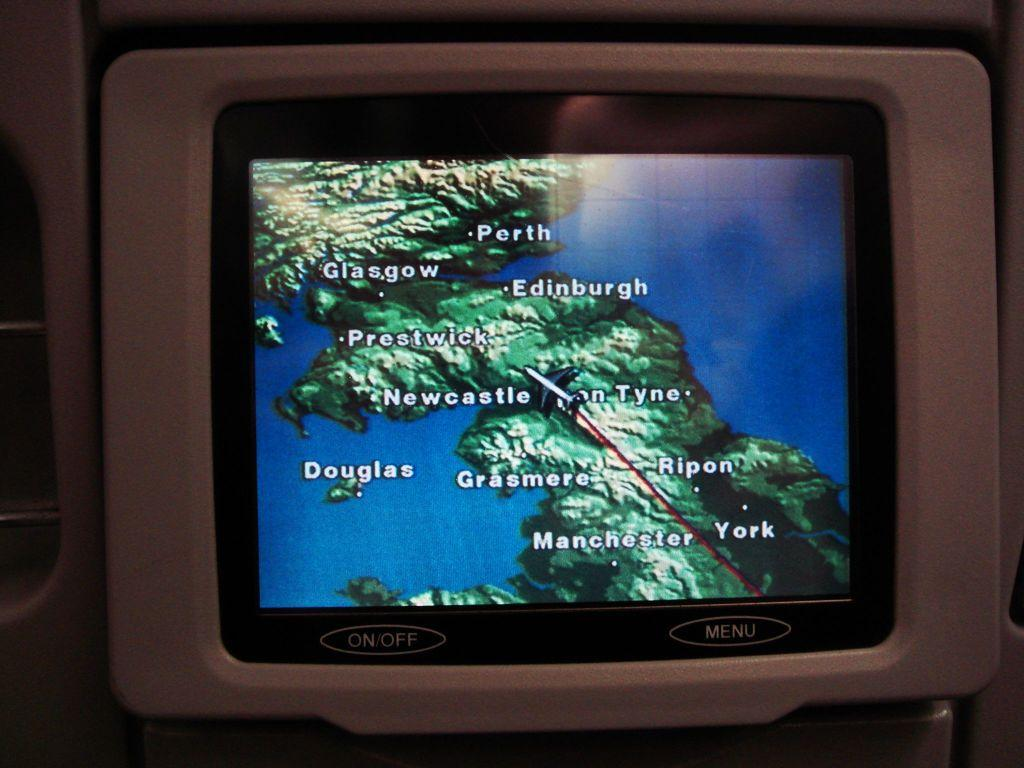What is the main object in the image? There is a screen in the image. What type of thought is being expressed by the turkey in the image? There is no turkey present in the image, and therefore no thoughts can be attributed to it. 